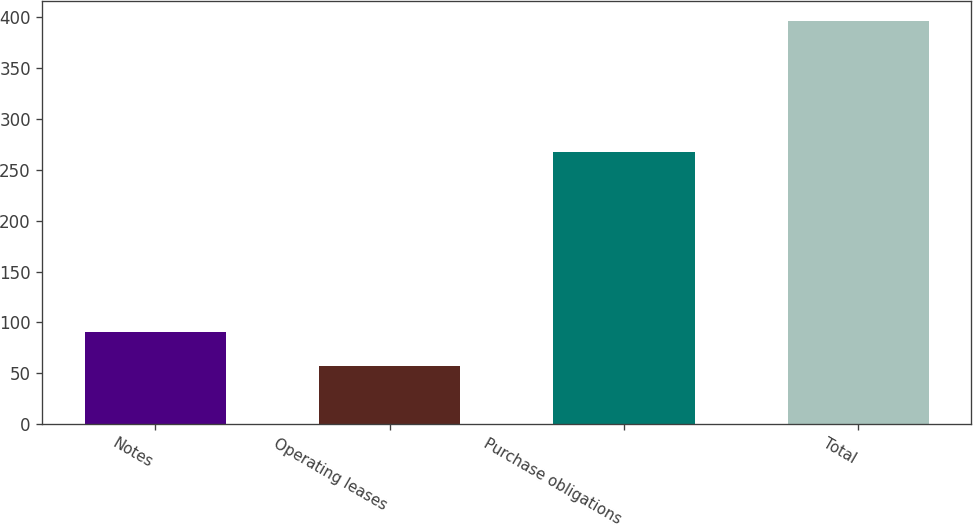<chart> <loc_0><loc_0><loc_500><loc_500><bar_chart><fcel>Notes<fcel>Operating leases<fcel>Purchase obligations<fcel>Total<nl><fcel>90.75<fcel>56.8<fcel>267.3<fcel>396.3<nl></chart> 